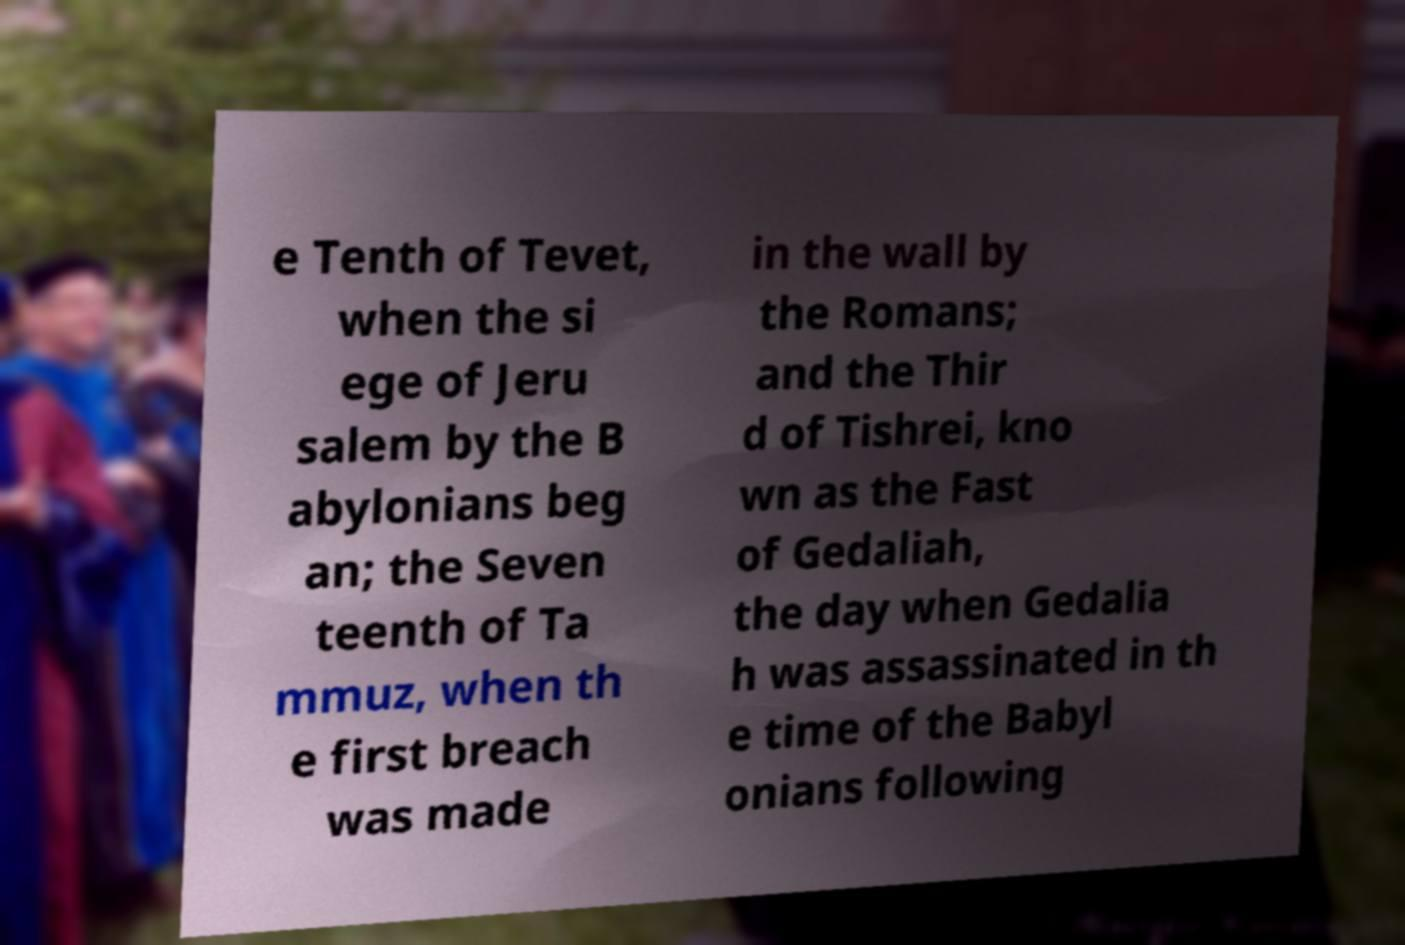Can you read and provide the text displayed in the image?This photo seems to have some interesting text. Can you extract and type it out for me? e Tenth of Tevet, when the si ege of Jeru salem by the B abylonians beg an; the Seven teenth of Ta mmuz, when th e first breach was made in the wall by the Romans; and the Thir d of Tishrei, kno wn as the Fast of Gedaliah, the day when Gedalia h was assassinated in th e time of the Babyl onians following 